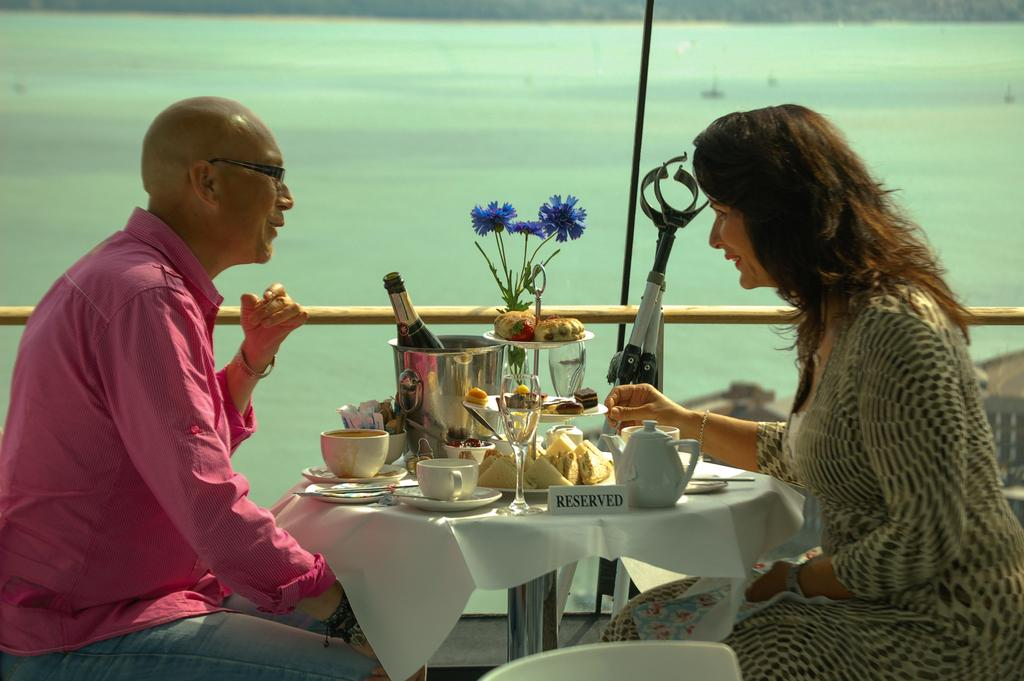Who is present in the image? There is a man and a woman in the image. What are they doing in the image? They are sitting at a table. What can be seen on the table? There is a wine bottle, cups, glasses, food items, and a flower vase on the table. What is visible in the background of the image? In the background, there is a pole and water. How many trees are visible in the image? There are no trees visible in the image. What part of the flower vase bursts in the image? There is no bursting part of the flower vase in the image, as it appears to be intact. 